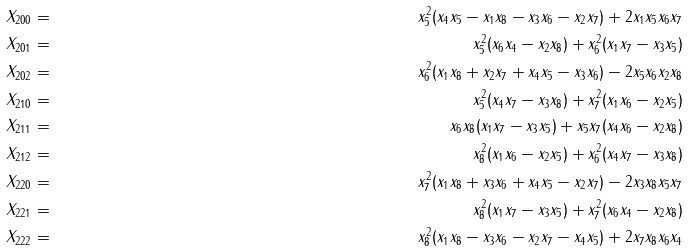Convert formula to latex. <formula><loc_0><loc_0><loc_500><loc_500>X _ { 2 0 0 } & = & x _ { 5 } ^ { 2 } ( x _ { 4 } x _ { 5 } - x _ { 1 } x _ { 8 } - x _ { 3 } x _ { 6 } - x _ { 2 } x _ { 7 } ) + 2 x _ { 1 } x _ { 5 } x _ { 6 } x _ { 7 } \\ X _ { 2 0 1 } & = & x _ { 5 } ^ { 2 } ( x _ { 6 } x _ { 4 } - x _ { 2 } x _ { 8 } ) + x _ { 6 } ^ { 2 } ( x _ { 1 } x _ { 7 } - x _ { 3 } x _ { 5 } ) \\ X _ { 2 0 2 } & = & x _ { 6 } ^ { 2 } ( x _ { 1 } x _ { 8 } + x _ { 2 } x _ { 7 } + x _ { 4 } x _ { 5 } - x _ { 3 } x _ { 6 } ) - 2 x _ { 5 } x _ { 6 } x _ { 2 } x _ { 8 } \\ X _ { 2 1 0 } & = & x _ { 5 } ^ { 2 } ( x _ { 4 } x _ { 7 } - x _ { 3 } x _ { 8 } ) + x _ { 7 } ^ { 2 } ( x _ { 1 } x _ { 6 } - x _ { 2 } x _ { 5 } ) \\ X _ { 2 1 1 } & = & x _ { 6 } x _ { 8 } ( x _ { 1 } x _ { 7 } - x _ { 3 } x _ { 5 } ) + x _ { 5 } x _ { 7 } ( x _ { 4 } x _ { 6 } - x _ { 2 } x _ { 8 } ) \\ X _ { 2 1 2 } & = & x _ { 8 } ^ { 2 } ( x _ { 1 } x _ { 6 } - x _ { 2 } x _ { 5 } ) + x _ { 6 } ^ { 2 } ( x _ { 4 } x _ { 7 } - x _ { 3 } x _ { 8 } ) \\ X _ { 2 2 0 } & = & x _ { 7 } ^ { 2 } ( x _ { 1 } x _ { 8 } + x _ { 3 } x _ { 6 } + x _ { 4 } x _ { 5 } - x _ { 2 } x _ { 7 } ) - 2 x _ { 3 } x _ { 8 } x _ { 5 } x _ { 7 } \\ X _ { 2 2 1 } & = & x _ { 8 } ^ { 2 } ( x _ { 1 } x _ { 7 } - x _ { 3 } x _ { 5 } ) + x _ { 7 } ^ { 2 } ( x _ { 6 } x _ { 4 } - x _ { 2 } x _ { 8 } ) \\ X _ { 2 2 2 } & = & x _ { 8 } ^ { 2 } ( x _ { 1 } x _ { 8 } - x _ { 3 } x _ { 6 } - x _ { 2 } x _ { 7 } - x _ { 4 } x _ { 5 } ) + 2 x _ { 7 } x _ { 8 } x _ { 6 } x _ { 4 }</formula> 